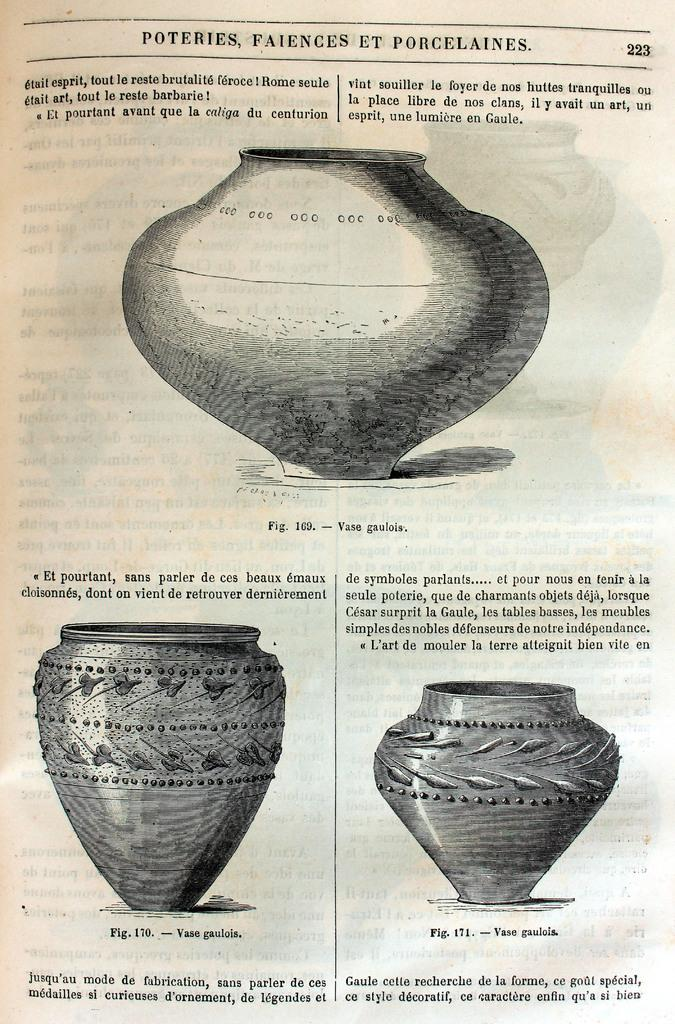What is present on the paper in the image? There is some matter written on the paper. What other objects can be seen in the image? There are pots in the image. What type of copper material is used to make the pots in the image? There is no mention of the material used to make the pots in the image, and there is no copper material present. How many bananas are visible in the image? There are no bananas present in the image. 